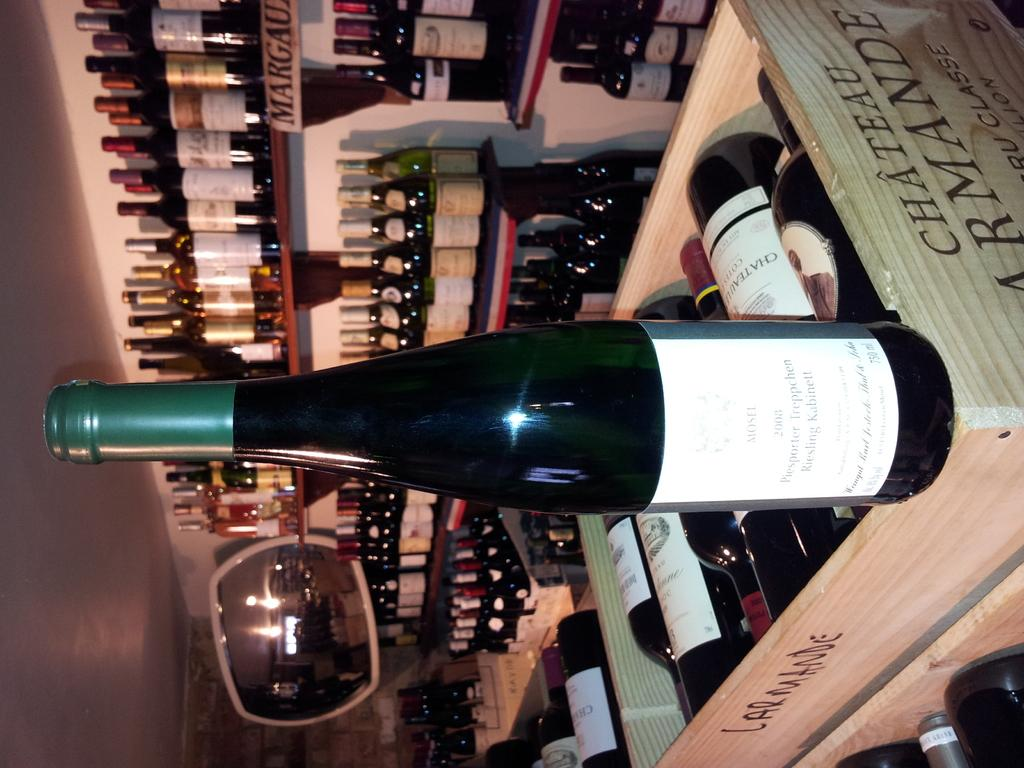What is in the wooden boxes in the foreground of the image? There are liquor bottles in wooden boxes in the foreground. What else can be seen in the foreground of the image? There are liquor bottles on shelves in the foreground. What can be seen in the background of the image? There is a wall, a mirror, and other objects visible in the background. Can you describe the setting of the image? The image may have been taken in a shop, as it contains a variety of liquor bottles. How many rabbits are sitting on the liquor bottles in the image? There are no rabbits present in the image; it only contains liquor bottles in wooden boxes and on shelves. What type of religious symbol can be seen in the image? There is no religious symbol present in the image. 